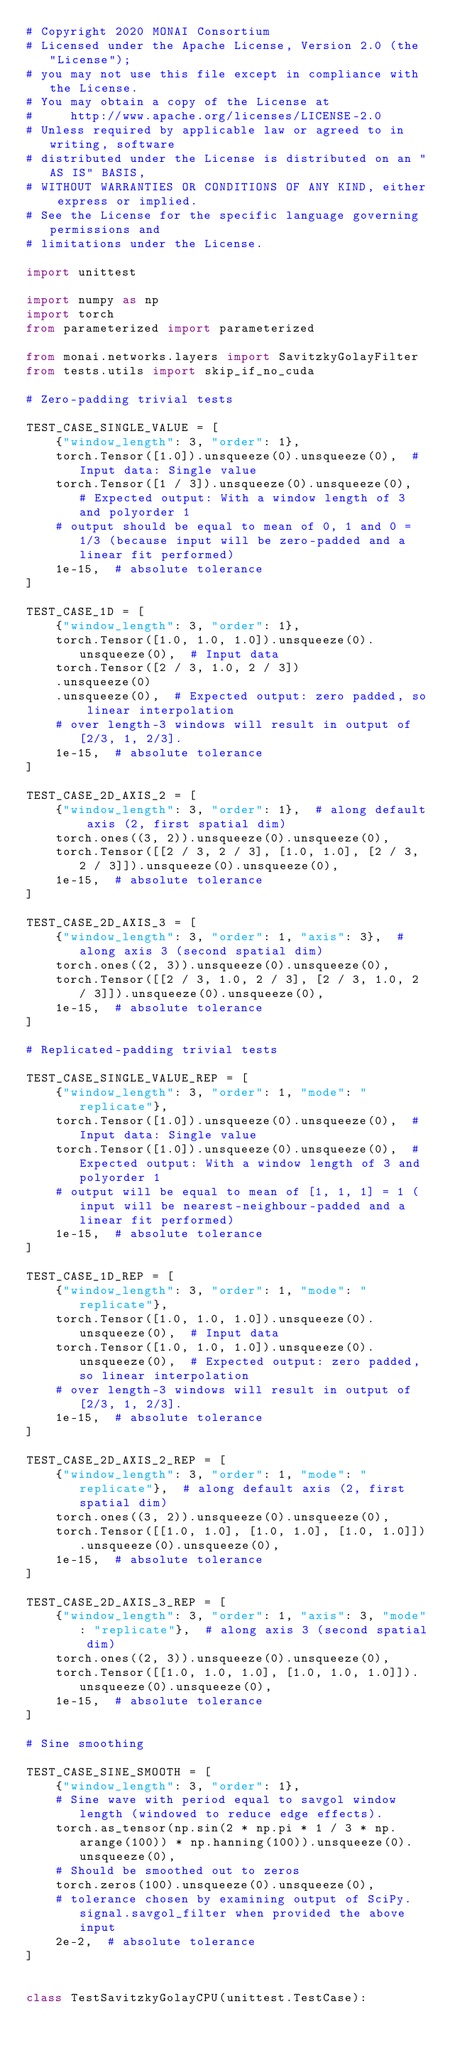Convert code to text. <code><loc_0><loc_0><loc_500><loc_500><_Python_># Copyright 2020 MONAI Consortium
# Licensed under the Apache License, Version 2.0 (the "License");
# you may not use this file except in compliance with the License.
# You may obtain a copy of the License at
#     http://www.apache.org/licenses/LICENSE-2.0
# Unless required by applicable law or agreed to in writing, software
# distributed under the License is distributed on an "AS IS" BASIS,
# WITHOUT WARRANTIES OR CONDITIONS OF ANY KIND, either express or implied.
# See the License for the specific language governing permissions and
# limitations under the License.

import unittest

import numpy as np
import torch
from parameterized import parameterized

from monai.networks.layers import SavitzkyGolayFilter
from tests.utils import skip_if_no_cuda

# Zero-padding trivial tests

TEST_CASE_SINGLE_VALUE = [
    {"window_length": 3, "order": 1},
    torch.Tensor([1.0]).unsqueeze(0).unsqueeze(0),  # Input data: Single value
    torch.Tensor([1 / 3]).unsqueeze(0).unsqueeze(0),  # Expected output: With a window length of 3 and polyorder 1
    # output should be equal to mean of 0, 1 and 0 = 1/3 (because input will be zero-padded and a linear fit performed)
    1e-15,  # absolute tolerance
]

TEST_CASE_1D = [
    {"window_length": 3, "order": 1},
    torch.Tensor([1.0, 1.0, 1.0]).unsqueeze(0).unsqueeze(0),  # Input data
    torch.Tensor([2 / 3, 1.0, 2 / 3])
    .unsqueeze(0)
    .unsqueeze(0),  # Expected output: zero padded, so linear interpolation
    # over length-3 windows will result in output of [2/3, 1, 2/3].
    1e-15,  # absolute tolerance
]

TEST_CASE_2D_AXIS_2 = [
    {"window_length": 3, "order": 1},  # along default axis (2, first spatial dim)
    torch.ones((3, 2)).unsqueeze(0).unsqueeze(0),
    torch.Tensor([[2 / 3, 2 / 3], [1.0, 1.0], [2 / 3, 2 / 3]]).unsqueeze(0).unsqueeze(0),
    1e-15,  # absolute tolerance
]

TEST_CASE_2D_AXIS_3 = [
    {"window_length": 3, "order": 1, "axis": 3},  # along axis 3 (second spatial dim)
    torch.ones((2, 3)).unsqueeze(0).unsqueeze(0),
    torch.Tensor([[2 / 3, 1.0, 2 / 3], [2 / 3, 1.0, 2 / 3]]).unsqueeze(0).unsqueeze(0),
    1e-15,  # absolute tolerance
]

# Replicated-padding trivial tests

TEST_CASE_SINGLE_VALUE_REP = [
    {"window_length": 3, "order": 1, "mode": "replicate"},
    torch.Tensor([1.0]).unsqueeze(0).unsqueeze(0),  # Input data: Single value
    torch.Tensor([1.0]).unsqueeze(0).unsqueeze(0),  # Expected output: With a window length of 3 and polyorder 1
    # output will be equal to mean of [1, 1, 1] = 1 (input will be nearest-neighbour-padded and a linear fit performed)
    1e-15,  # absolute tolerance
]

TEST_CASE_1D_REP = [
    {"window_length": 3, "order": 1, "mode": "replicate"},
    torch.Tensor([1.0, 1.0, 1.0]).unsqueeze(0).unsqueeze(0),  # Input data
    torch.Tensor([1.0, 1.0, 1.0]).unsqueeze(0).unsqueeze(0),  # Expected output: zero padded, so linear interpolation
    # over length-3 windows will result in output of [2/3, 1, 2/3].
    1e-15,  # absolute tolerance
]

TEST_CASE_2D_AXIS_2_REP = [
    {"window_length": 3, "order": 1, "mode": "replicate"},  # along default axis (2, first spatial dim)
    torch.ones((3, 2)).unsqueeze(0).unsqueeze(0),
    torch.Tensor([[1.0, 1.0], [1.0, 1.0], [1.0, 1.0]]).unsqueeze(0).unsqueeze(0),
    1e-15,  # absolute tolerance
]

TEST_CASE_2D_AXIS_3_REP = [
    {"window_length": 3, "order": 1, "axis": 3, "mode": "replicate"},  # along axis 3 (second spatial dim)
    torch.ones((2, 3)).unsqueeze(0).unsqueeze(0),
    torch.Tensor([[1.0, 1.0, 1.0], [1.0, 1.0, 1.0]]).unsqueeze(0).unsqueeze(0),
    1e-15,  # absolute tolerance
]

# Sine smoothing

TEST_CASE_SINE_SMOOTH = [
    {"window_length": 3, "order": 1},
    # Sine wave with period equal to savgol window length (windowed to reduce edge effects).
    torch.as_tensor(np.sin(2 * np.pi * 1 / 3 * np.arange(100)) * np.hanning(100)).unsqueeze(0).unsqueeze(0),
    # Should be smoothed out to zeros
    torch.zeros(100).unsqueeze(0).unsqueeze(0),
    # tolerance chosen by examining output of SciPy.signal.savgol_filter when provided the above input
    2e-2,  # absolute tolerance
]


class TestSavitzkyGolayCPU(unittest.TestCase):</code> 